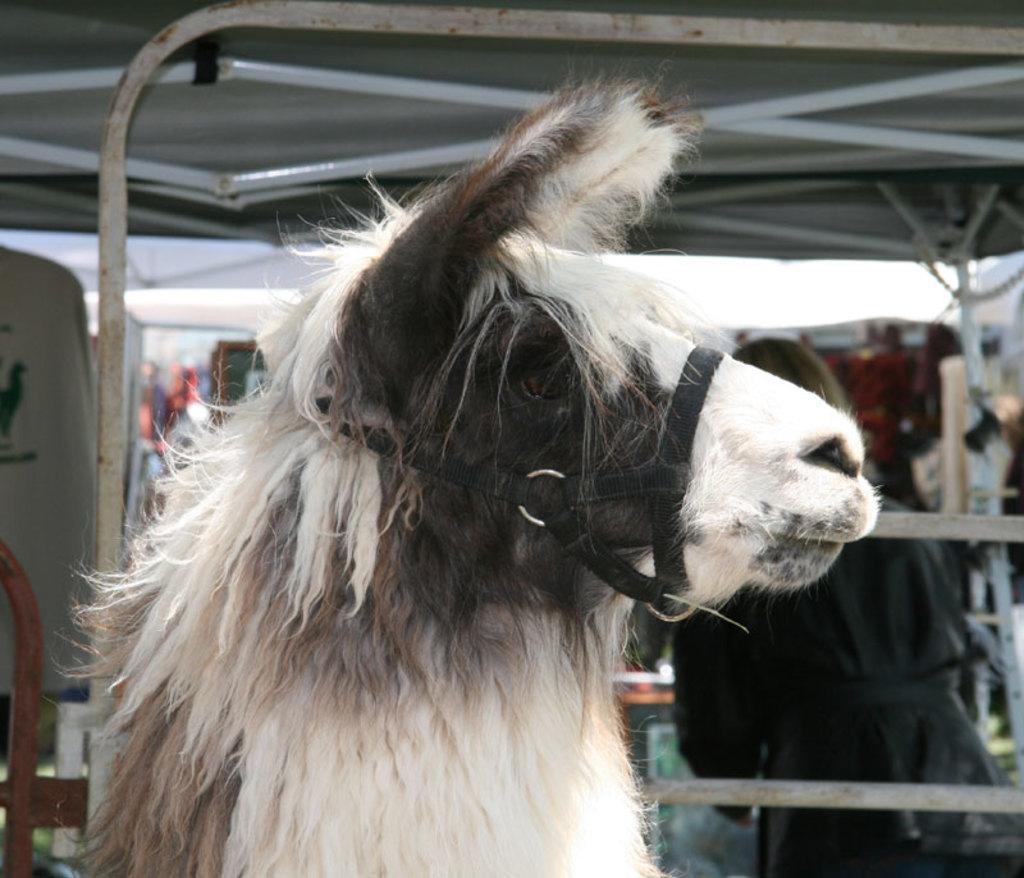Please provide a concise description of this image. In this image there is a horse, in the background there is a shed, in that shed there is a person. 